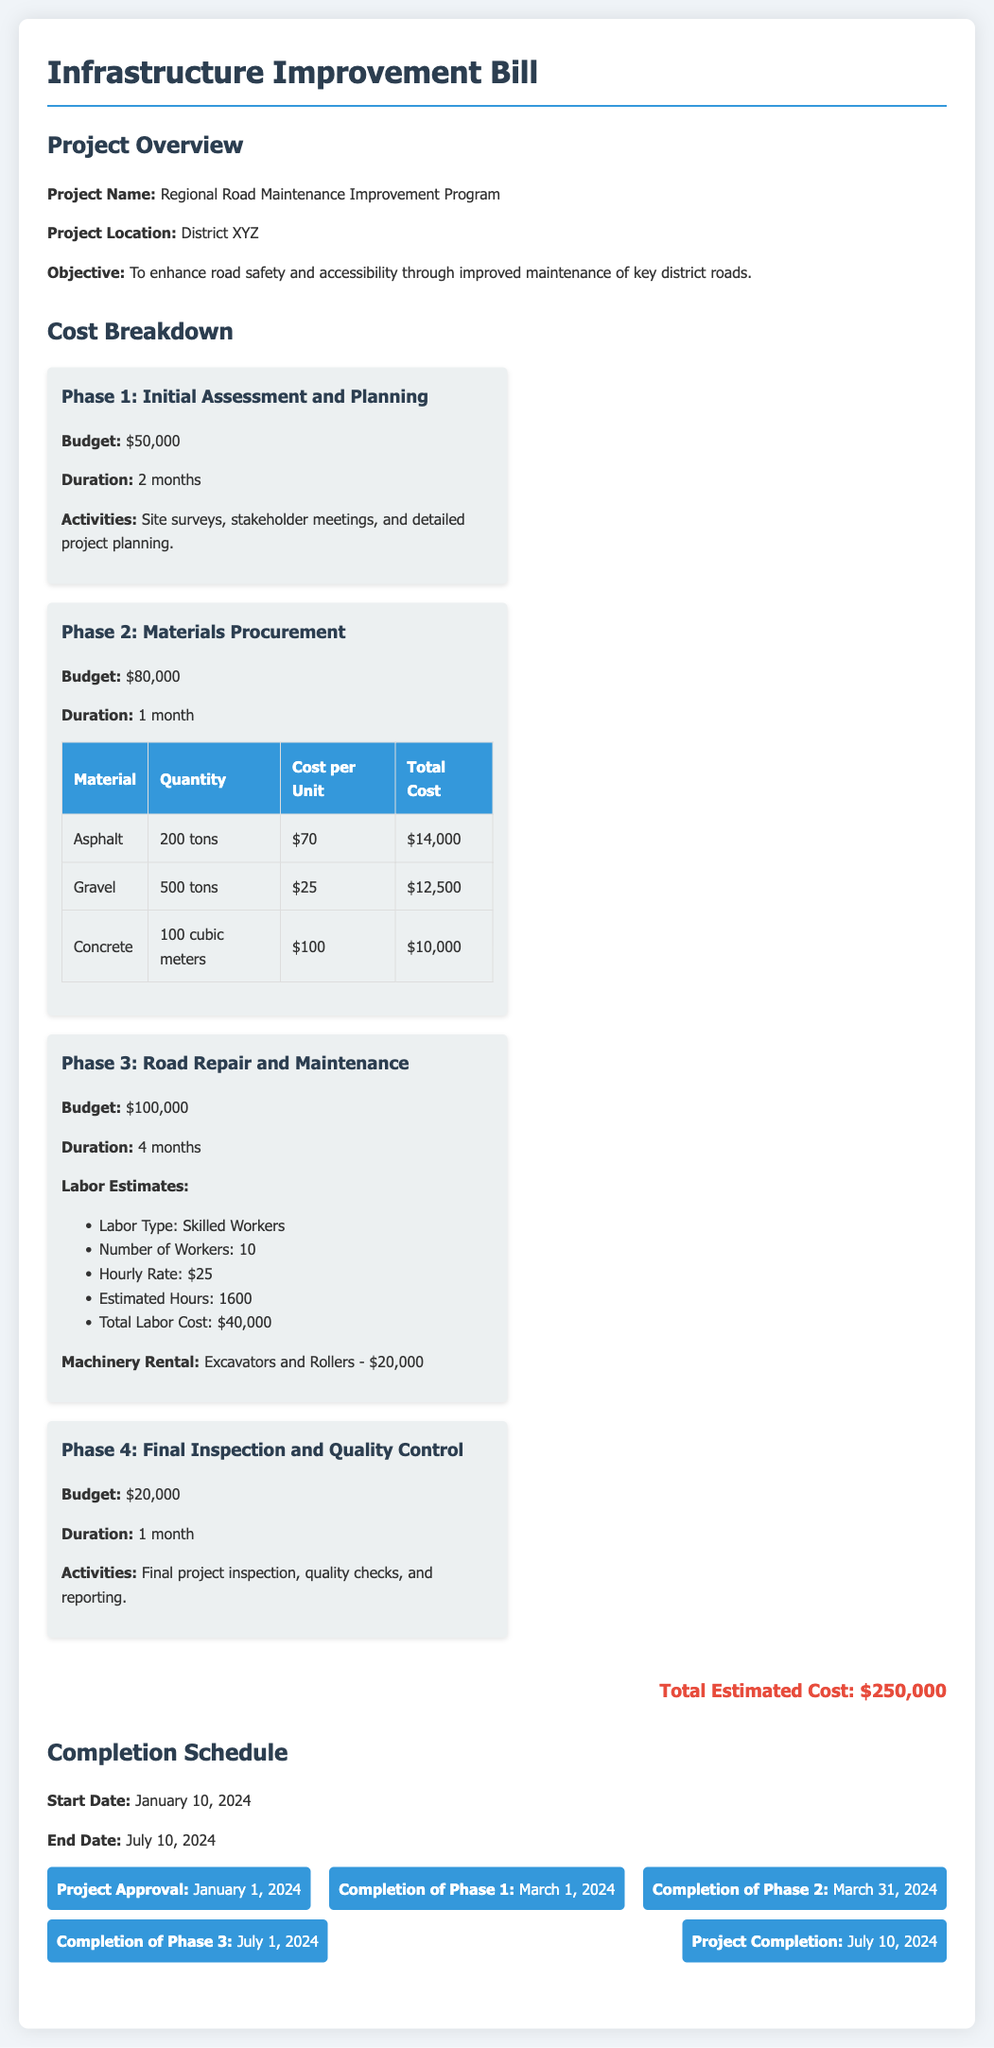what is the project name? The project name is stated in the document as "Regional Road Maintenance Improvement Program."
Answer: Regional Road Maintenance Improvement Program what is the total estimated cost? The document specifies the total estimated cost at the end of the cost breakdown section as $250,000.
Answer: $250,000 how long is the duration of Phase 2? The duration of Phase 2 is clearly noted in the document as 1 month.
Answer: 1 month what is the budget allocated for Phase 3? The budget for Phase 3 is mentioned in the document as $100,000.
Answer: $100,000 when is the project expected to start? The expected start date of the project is specified in the completion schedule as January 10, 2024.
Answer: January 10, 2024 how many workers are estimated for Phase 3? The document indicates that 10 workers are estimated for Phase 3.
Answer: 10 what is the cost per unit of asphalt? The cost per unit of asphalt is given in the materials procurement section as $70.
Answer: $70 what is the duration of the entire project? The overall project duration can be calculated from the start and end dates listed as January 10, 2024, to July 10, 2024, which is 6 months.
Answer: 6 months what is the primary objective of the project? The primary objective of the project is stated as enhancing road safety and accessibility through improved maintenance.
Answer: To enhance road safety and accessibility 